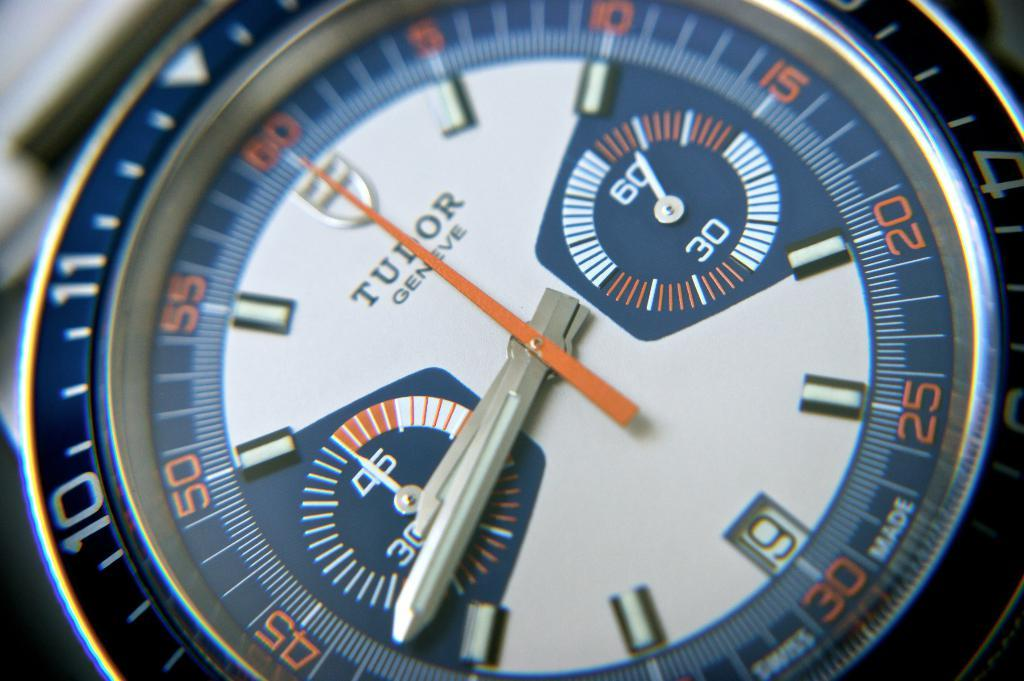<image>
Offer a succinct explanation of the picture presented. A blue, orange and white, Tudor Geneve , watch shows the time as 8:42. 